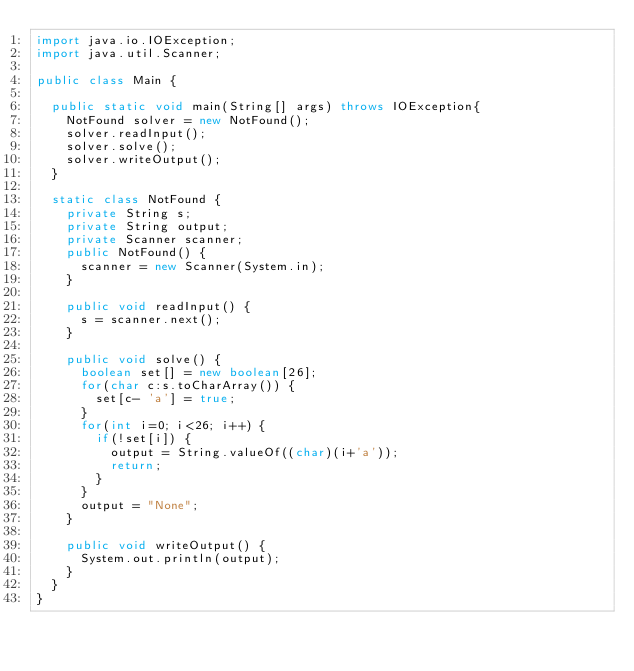<code> <loc_0><loc_0><loc_500><loc_500><_Java_>import java.io.IOException;
import java.util.Scanner;

public class Main {

	public static void main(String[] args) throws IOException{
		NotFound solver = new NotFound();
		solver.readInput();
		solver.solve();
		solver.writeOutput();
	}

	static class NotFound {
		private String s;
		private String output;
		private Scanner scanner;
		public NotFound() {
			scanner = new Scanner(System.in);
		}

		public void readInput() {
			s = scanner.next();
		}

		public void solve() {
			boolean set[] = new boolean[26];
			for(char c:s.toCharArray()) {
				set[c- 'a'] = true;
			}
			for(int i=0; i<26; i++) {
				if(!set[i]) {
					output = String.valueOf((char)(i+'a'));
					return;
				}
			}
			output = "None";
		}

		public void writeOutput() {
			System.out.println(output);
		}
	}
}
</code> 